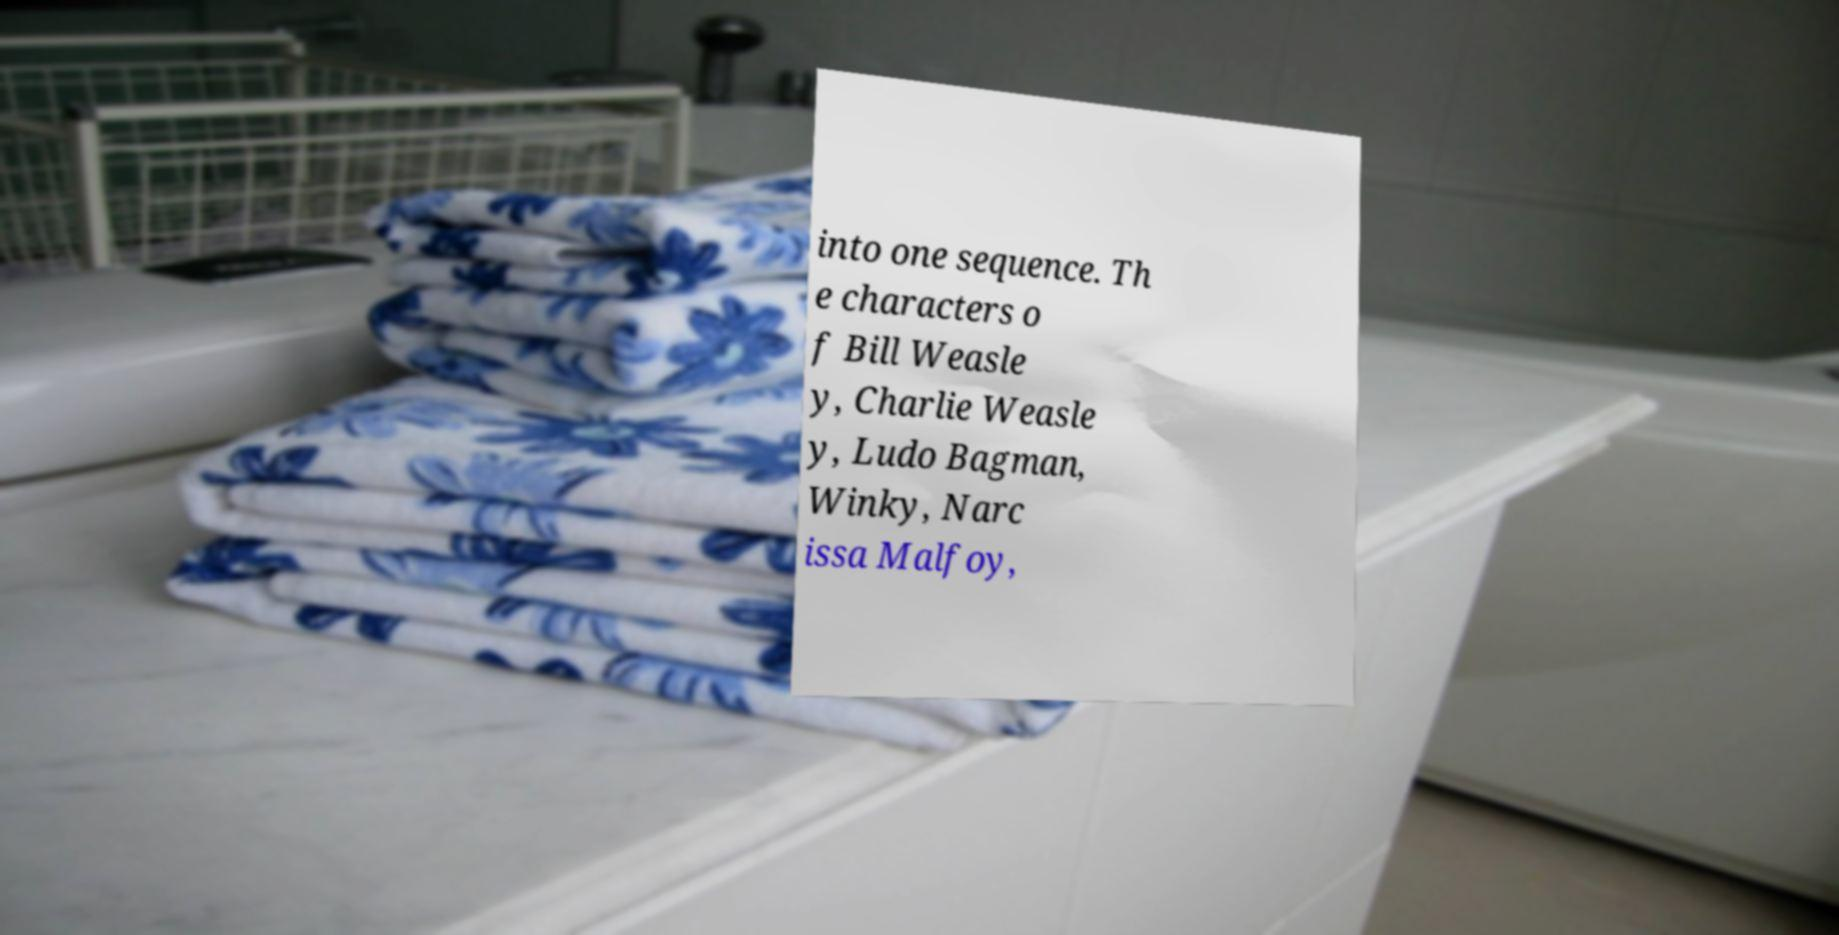Could you extract and type out the text from this image? into one sequence. Th e characters o f Bill Weasle y, Charlie Weasle y, Ludo Bagman, Winky, Narc issa Malfoy, 